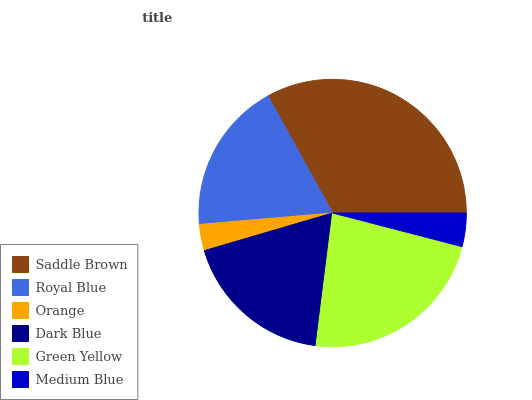Is Orange the minimum?
Answer yes or no. Yes. Is Saddle Brown the maximum?
Answer yes or no. Yes. Is Royal Blue the minimum?
Answer yes or no. No. Is Royal Blue the maximum?
Answer yes or no. No. Is Saddle Brown greater than Royal Blue?
Answer yes or no. Yes. Is Royal Blue less than Saddle Brown?
Answer yes or no. Yes. Is Royal Blue greater than Saddle Brown?
Answer yes or no. No. Is Saddle Brown less than Royal Blue?
Answer yes or no. No. Is Dark Blue the high median?
Answer yes or no. Yes. Is Royal Blue the low median?
Answer yes or no. Yes. Is Royal Blue the high median?
Answer yes or no. No. Is Medium Blue the low median?
Answer yes or no. No. 